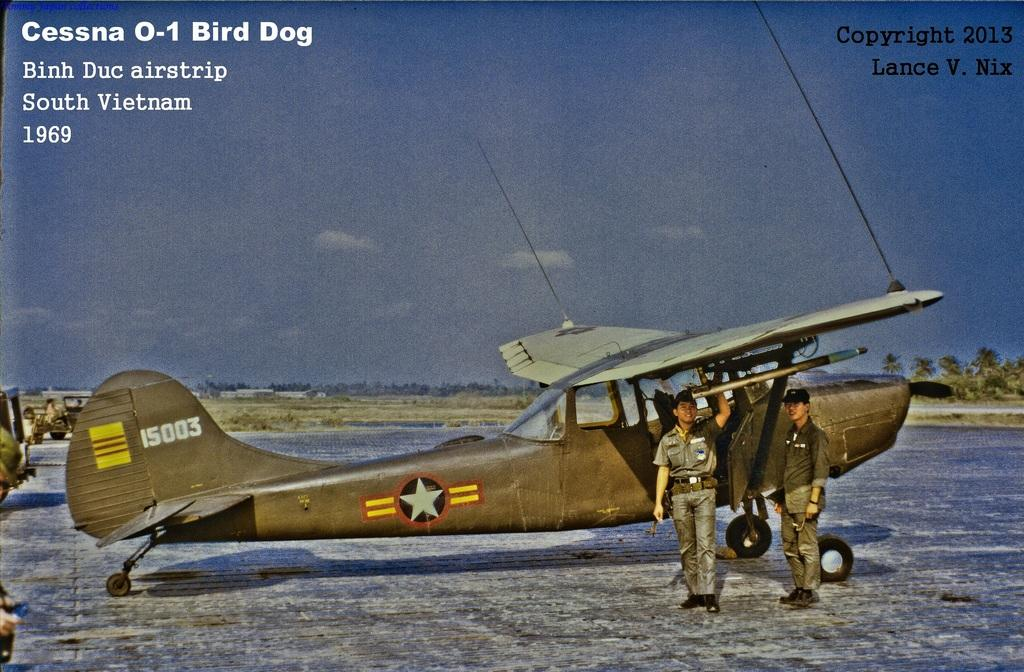<image>
Provide a brief description of the given image. Old plane that is from South Vietnam airstrip 